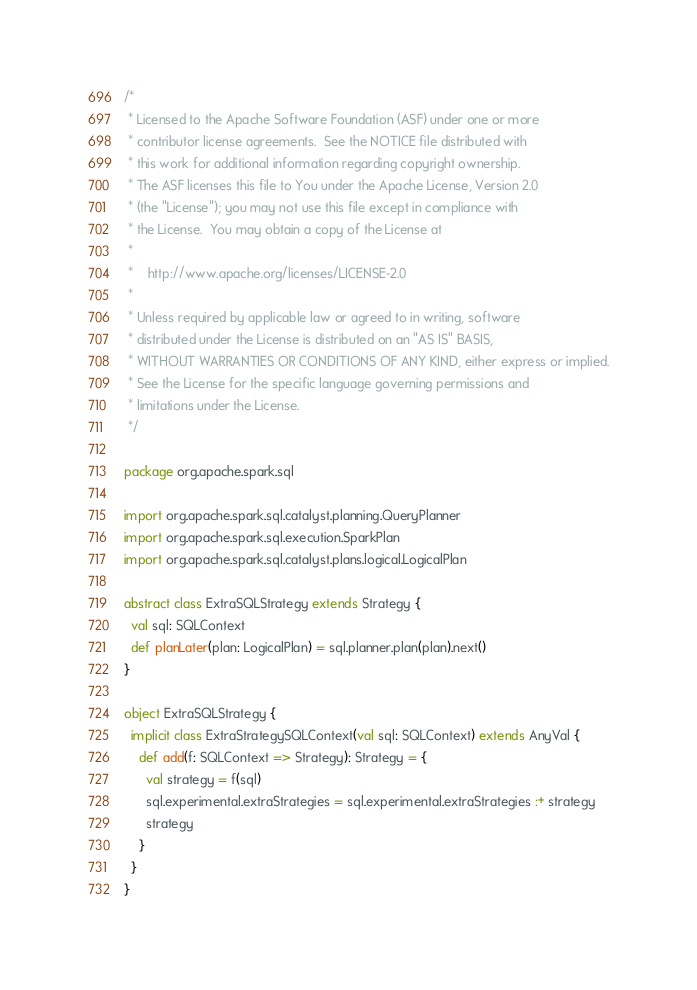Convert code to text. <code><loc_0><loc_0><loc_500><loc_500><_Scala_>/*
 * Licensed to the Apache Software Foundation (ASF) under one or more
 * contributor license agreements.  See the NOTICE file distributed with
 * this work for additional information regarding copyright ownership.
 * The ASF licenses this file to You under the Apache License, Version 2.0
 * (the "License"); you may not use this file except in compliance with
 * the License.  You may obtain a copy of the License at
 *
 *    http://www.apache.org/licenses/LICENSE-2.0
 *
 * Unless required by applicable law or agreed to in writing, software
 * distributed under the License is distributed on an "AS IS" BASIS,
 * WITHOUT WARRANTIES OR CONDITIONS OF ANY KIND, either express or implied.
 * See the License for the specific language governing permissions and
 * limitations under the License.
 */

package org.apache.spark.sql

import org.apache.spark.sql.catalyst.planning.QueryPlanner
import org.apache.spark.sql.execution.SparkPlan
import org.apache.spark.sql.catalyst.plans.logical.LogicalPlan

abstract class ExtraSQLStrategy extends Strategy {
  val sql: SQLContext
  def planLater(plan: LogicalPlan) = sql.planner.plan(plan).next()
}

object ExtraSQLStrategy {
  implicit class ExtraStrategySQLContext(val sql: SQLContext) extends AnyVal {
    def add(f: SQLContext => Strategy): Strategy = {
      val strategy = f(sql)
      sql.experimental.extraStrategies = sql.experimental.extraStrategies :+ strategy
      strategy
    }
  }
}</code> 